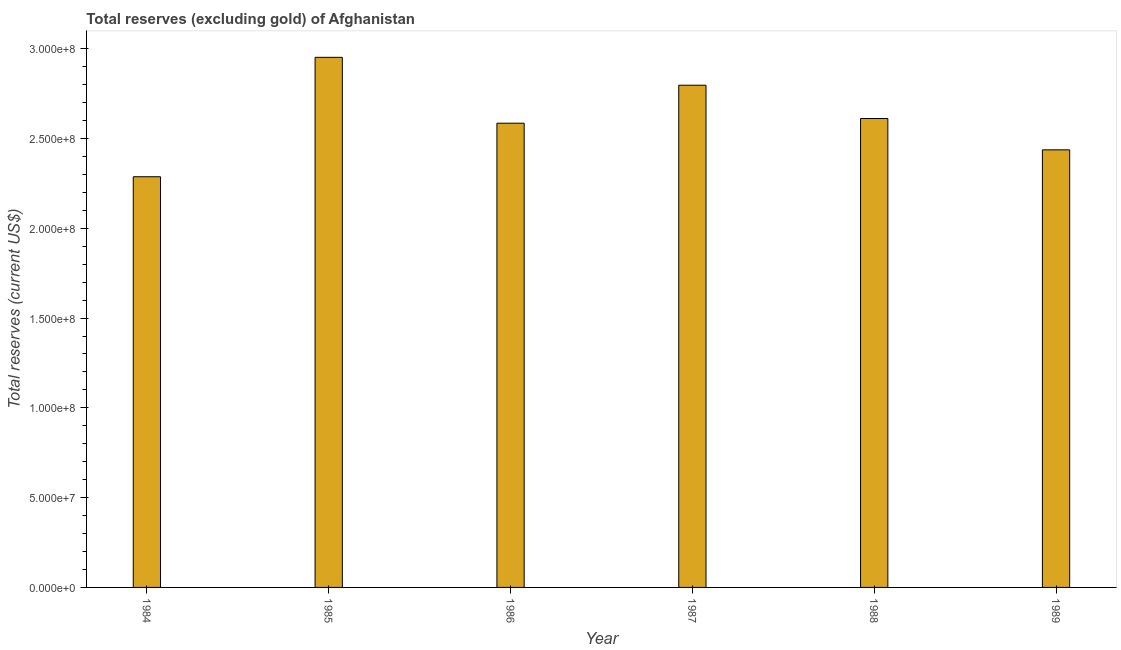Does the graph contain any zero values?
Keep it short and to the point. No. What is the title of the graph?
Your answer should be compact. Total reserves (excluding gold) of Afghanistan. What is the label or title of the Y-axis?
Offer a terse response. Total reserves (current US$). What is the total reserves (excluding gold) in 1989?
Offer a very short reply. 2.44e+08. Across all years, what is the maximum total reserves (excluding gold)?
Your answer should be compact. 2.95e+08. Across all years, what is the minimum total reserves (excluding gold)?
Provide a succinct answer. 2.29e+08. In which year was the total reserves (excluding gold) maximum?
Your answer should be very brief. 1985. What is the sum of the total reserves (excluding gold)?
Offer a terse response. 1.57e+09. What is the difference between the total reserves (excluding gold) in 1987 and 1989?
Keep it short and to the point. 3.60e+07. What is the average total reserves (excluding gold) per year?
Give a very brief answer. 2.61e+08. What is the median total reserves (excluding gold)?
Make the answer very short. 2.60e+08. In how many years, is the total reserves (excluding gold) greater than 70000000 US$?
Offer a terse response. 6. Do a majority of the years between 1986 and 1985 (inclusive) have total reserves (excluding gold) greater than 150000000 US$?
Your answer should be very brief. No. What is the ratio of the total reserves (excluding gold) in 1985 to that in 1986?
Ensure brevity in your answer.  1.14. Is the difference between the total reserves (excluding gold) in 1987 and 1989 greater than the difference between any two years?
Your response must be concise. No. What is the difference between the highest and the second highest total reserves (excluding gold)?
Provide a succinct answer. 1.55e+07. What is the difference between the highest and the lowest total reserves (excluding gold)?
Offer a terse response. 6.65e+07. Are all the bars in the graph horizontal?
Keep it short and to the point. No. What is the Total reserves (current US$) in 1984?
Make the answer very short. 2.29e+08. What is the Total reserves (current US$) of 1985?
Keep it short and to the point. 2.95e+08. What is the Total reserves (current US$) in 1986?
Provide a succinct answer. 2.59e+08. What is the Total reserves (current US$) in 1987?
Keep it short and to the point. 2.80e+08. What is the Total reserves (current US$) in 1988?
Offer a very short reply. 2.61e+08. What is the Total reserves (current US$) of 1989?
Your answer should be very brief. 2.44e+08. What is the difference between the Total reserves (current US$) in 1984 and 1985?
Offer a very short reply. -6.65e+07. What is the difference between the Total reserves (current US$) in 1984 and 1986?
Your response must be concise. -2.98e+07. What is the difference between the Total reserves (current US$) in 1984 and 1987?
Offer a terse response. -5.10e+07. What is the difference between the Total reserves (current US$) in 1984 and 1988?
Offer a very short reply. -3.24e+07. What is the difference between the Total reserves (current US$) in 1984 and 1989?
Ensure brevity in your answer.  -1.50e+07. What is the difference between the Total reserves (current US$) in 1985 and 1986?
Provide a short and direct response. 3.67e+07. What is the difference between the Total reserves (current US$) in 1985 and 1987?
Make the answer very short. 1.55e+07. What is the difference between the Total reserves (current US$) in 1985 and 1988?
Your answer should be very brief. 3.41e+07. What is the difference between the Total reserves (current US$) in 1985 and 1989?
Your answer should be very brief. 5.15e+07. What is the difference between the Total reserves (current US$) in 1986 and 1987?
Your answer should be very brief. -2.12e+07. What is the difference between the Total reserves (current US$) in 1986 and 1988?
Provide a short and direct response. -2.60e+06. What is the difference between the Total reserves (current US$) in 1986 and 1989?
Ensure brevity in your answer.  1.48e+07. What is the difference between the Total reserves (current US$) in 1987 and 1988?
Provide a succinct answer. 1.86e+07. What is the difference between the Total reserves (current US$) in 1987 and 1989?
Provide a short and direct response. 3.60e+07. What is the difference between the Total reserves (current US$) in 1988 and 1989?
Offer a very short reply. 1.74e+07. What is the ratio of the Total reserves (current US$) in 1984 to that in 1985?
Ensure brevity in your answer.  0.78. What is the ratio of the Total reserves (current US$) in 1984 to that in 1986?
Your answer should be compact. 0.89. What is the ratio of the Total reserves (current US$) in 1984 to that in 1987?
Keep it short and to the point. 0.82. What is the ratio of the Total reserves (current US$) in 1984 to that in 1988?
Keep it short and to the point. 0.88. What is the ratio of the Total reserves (current US$) in 1984 to that in 1989?
Your answer should be very brief. 0.94. What is the ratio of the Total reserves (current US$) in 1985 to that in 1986?
Your answer should be compact. 1.14. What is the ratio of the Total reserves (current US$) in 1985 to that in 1987?
Offer a terse response. 1.06. What is the ratio of the Total reserves (current US$) in 1985 to that in 1988?
Give a very brief answer. 1.13. What is the ratio of the Total reserves (current US$) in 1985 to that in 1989?
Make the answer very short. 1.21. What is the ratio of the Total reserves (current US$) in 1986 to that in 1987?
Provide a short and direct response. 0.92. What is the ratio of the Total reserves (current US$) in 1986 to that in 1988?
Give a very brief answer. 0.99. What is the ratio of the Total reserves (current US$) in 1986 to that in 1989?
Offer a terse response. 1.06. What is the ratio of the Total reserves (current US$) in 1987 to that in 1988?
Your answer should be compact. 1.07. What is the ratio of the Total reserves (current US$) in 1987 to that in 1989?
Your answer should be compact. 1.15. What is the ratio of the Total reserves (current US$) in 1988 to that in 1989?
Offer a terse response. 1.07. 